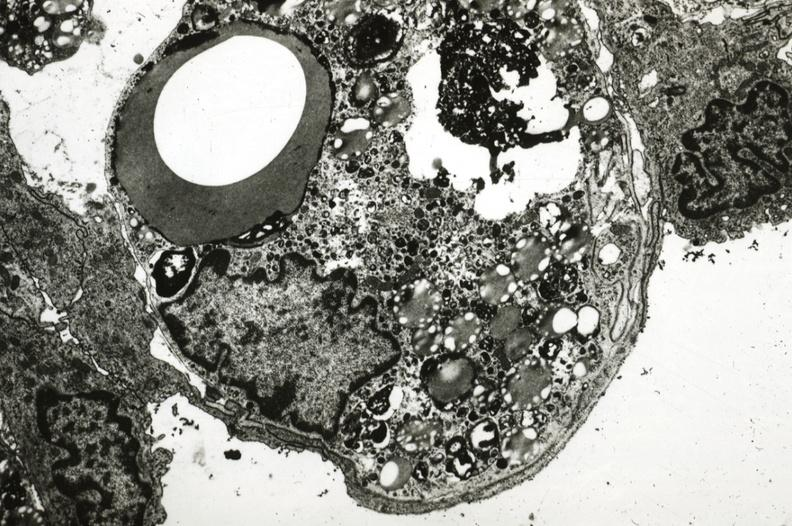s cardiovascular present?
Answer the question using a single word or phrase. Yes 